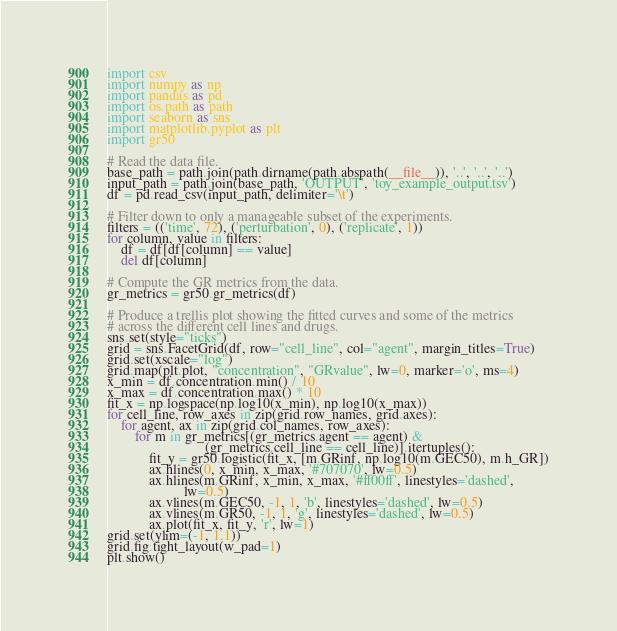<code> <loc_0><loc_0><loc_500><loc_500><_Python_>import csv
import numpy as np
import pandas as pd
import os.path as path
import seaborn as sns
import matplotlib.pyplot as plt
import gr50

# Read the data file.
base_path = path.join(path.dirname(path.abspath(__file__)), '..', '..', '..')
input_path = path.join(base_path, 'OUTPUT', 'toy_example_output.tsv')
df = pd.read_csv(input_path, delimiter='\t')

# Filter down to only a manageable subset of the experiments.
filters = (('time', 72), ('perturbation', 0), ('replicate', 1))
for column, value in filters:
    df = df[df[column] == value]
    del df[column]

# Compute the GR metrics from the data.
gr_metrics = gr50.gr_metrics(df)

# Produce a trellis plot showing the fitted curves and some of the metrics
# across the different cell lines and drugs.
sns.set(style="ticks")
grid = sns.FacetGrid(df, row="cell_line", col="agent", margin_titles=True)
grid.set(xscale="log")
grid.map(plt.plot, "concentration", "GRvalue", lw=0, marker='o', ms=4)
x_min = df.concentration.min() / 10
x_max = df.concentration.max() * 10
fit_x = np.logspace(np.log10(x_min), np.log10(x_max))
for cell_line, row_axes in zip(grid.row_names, grid.axes):
    for agent, ax in zip(grid.col_names, row_axes):
        for m in gr_metrics[(gr_metrics.agent == agent) &
                            (gr_metrics.cell_line == cell_line)].itertuples():
            fit_y = gr50.logistic(fit_x, [m.GRinf, np.log10(m.GEC50), m.h_GR])
            ax.hlines(0, x_min, x_max, '#707070', lw=0.5)
            ax.hlines(m.GRinf, x_min, x_max, '#ff00ff', linestyles='dashed',
                      lw=0.5)
            ax.vlines(m.GEC50, -1, 1, 'b', linestyles='dashed', lw=0.5)
            ax.vlines(m.GR50, -1, 1, 'g', linestyles='dashed', lw=0.5)
            ax.plot(fit_x, fit_y, 'r', lw=1)
grid.set(ylim=(-1, 1.1))
grid.fig.tight_layout(w_pad=1)
plt.show()
</code> 